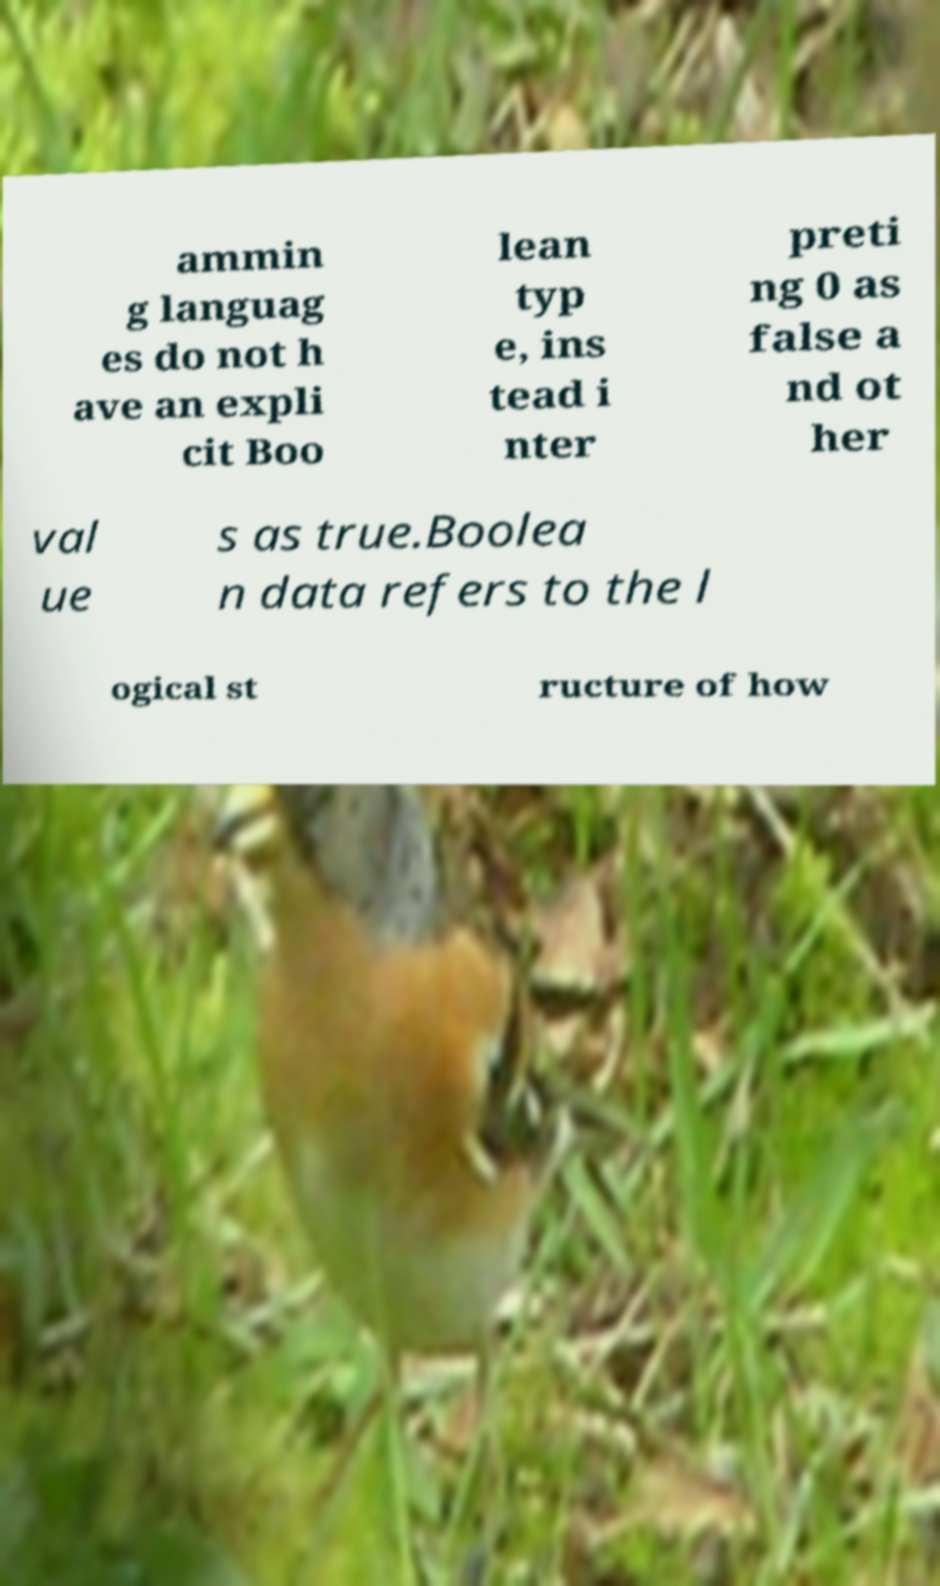Could you assist in decoding the text presented in this image and type it out clearly? ammin g languag es do not h ave an expli cit Boo lean typ e, ins tead i nter preti ng 0 as false a nd ot her val ue s as true.Boolea n data refers to the l ogical st ructure of how 